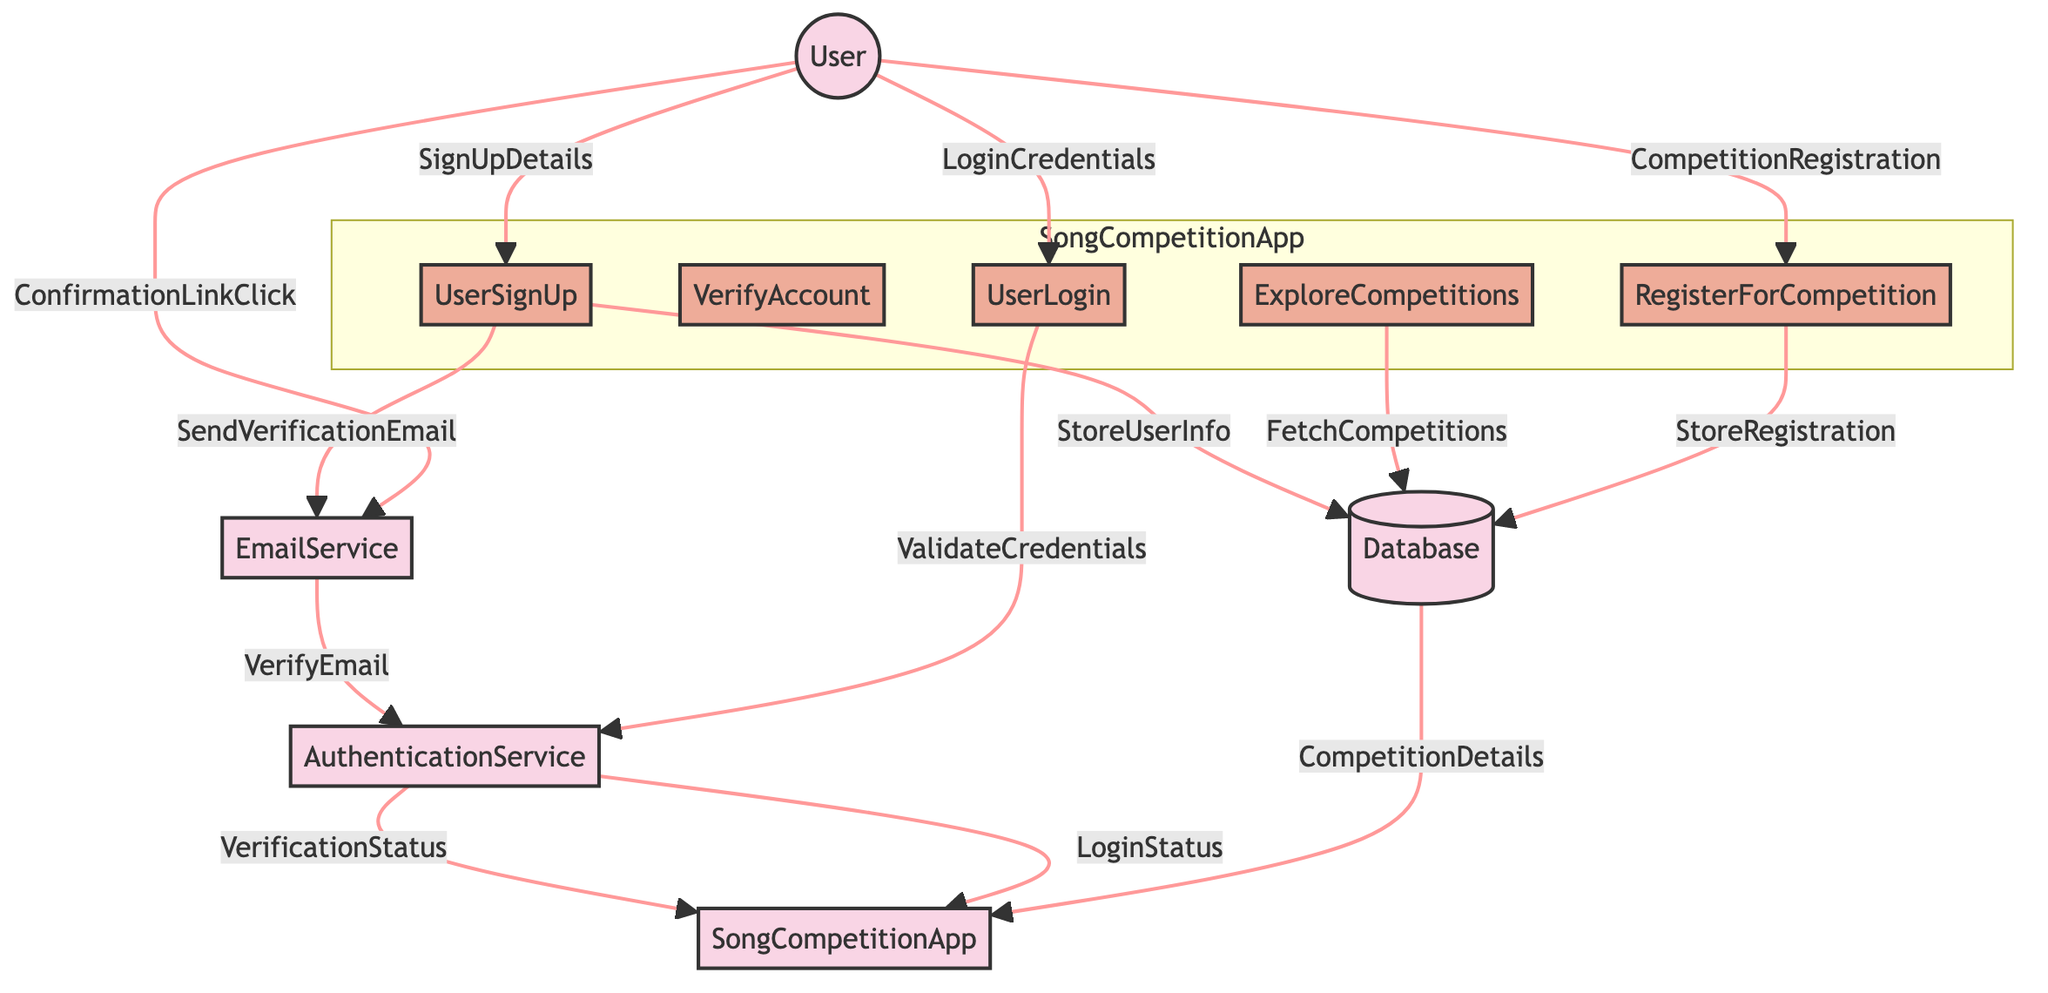What is the first process a user goes through when signing up? The diagram shows that the User first provides SignUpDetails to the UserSignUp process. Thus, the first process is UserSignUp.
Answer: UserSignUp How many services are involved in the diagram? The diagram identifies four services: SongCompetitionApp, AuthenticationService, EmailService, and Database. Counting these gives us a total of four services.
Answer: Four What does the AuthenticationService send back to the SongCompetitionApp? After the email is verified, the AuthenticationService returns the VerificationStatus to the SongCompetitionApp according to the data flow shown in the diagram.
Answer: VerificationStatus Which process follows after the User clicks on the confirmation link? Once the User clicks on the confirmation link, it results in the EmailService verifying the email through the VerifyEmail process. Therefore, the next process is VerifyEmail.
Answer: VerifyEmail Where do the competition details come from? The diagram indicates that the Database provides CompetitionDetails sent back to the SongCompetitionApp in response to a fetch request. Hence, the source of competition details is the Database.
Answer: Database What is the outcome of providing LoginCredentials? The outcome is that the Application sends the credentials to the AuthenticationService for validation and awaits a response regarding LoginStatus, indicating whether the login is successful or not.
Answer: LoginStatus How does the UserSignUp process relate to the Database? The UserSignUp process interacts with the Database by storing user information, as shown by the StoreUserInfo data flow outgoing from UserSignUp and directed towards the Database.
Answer: StoreUserInfo In total, how many processes are presented in the diagram? The diagram displays five distinct processes: UserSignUp, VerifyAccount, UserLogin, ExploreCompetitions, and RegisterForCompetition. Therefore, the total number of processes is five.
Answer: Five What action does the EmailService perform after receiving the confirmation link from the User? After receiving the confirmation link, the EmailService performs the action of verifying the email through its VerifyEmail process, sending the request to the AuthenticationService.
Answer: VerifyEmail 